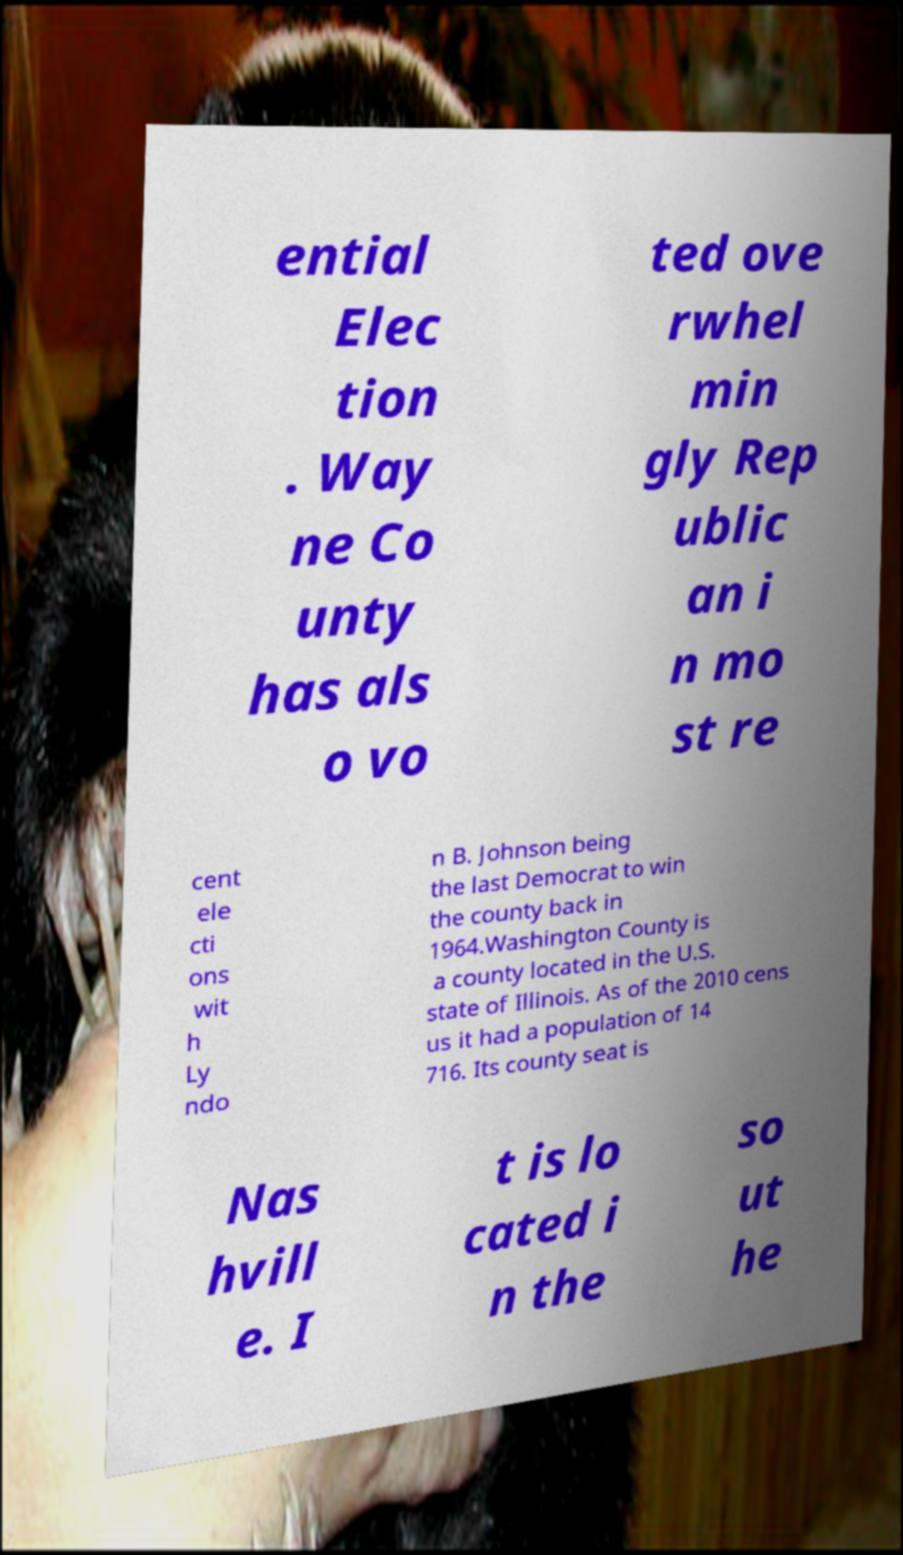What messages or text are displayed in this image? I need them in a readable, typed format. ential Elec tion . Way ne Co unty has als o vo ted ove rwhel min gly Rep ublic an i n mo st re cent ele cti ons wit h Ly ndo n B. Johnson being the last Democrat to win the county back in 1964.Washington County is a county located in the U.S. state of Illinois. As of the 2010 cens us it had a population of 14 716. Its county seat is Nas hvill e. I t is lo cated i n the so ut he 